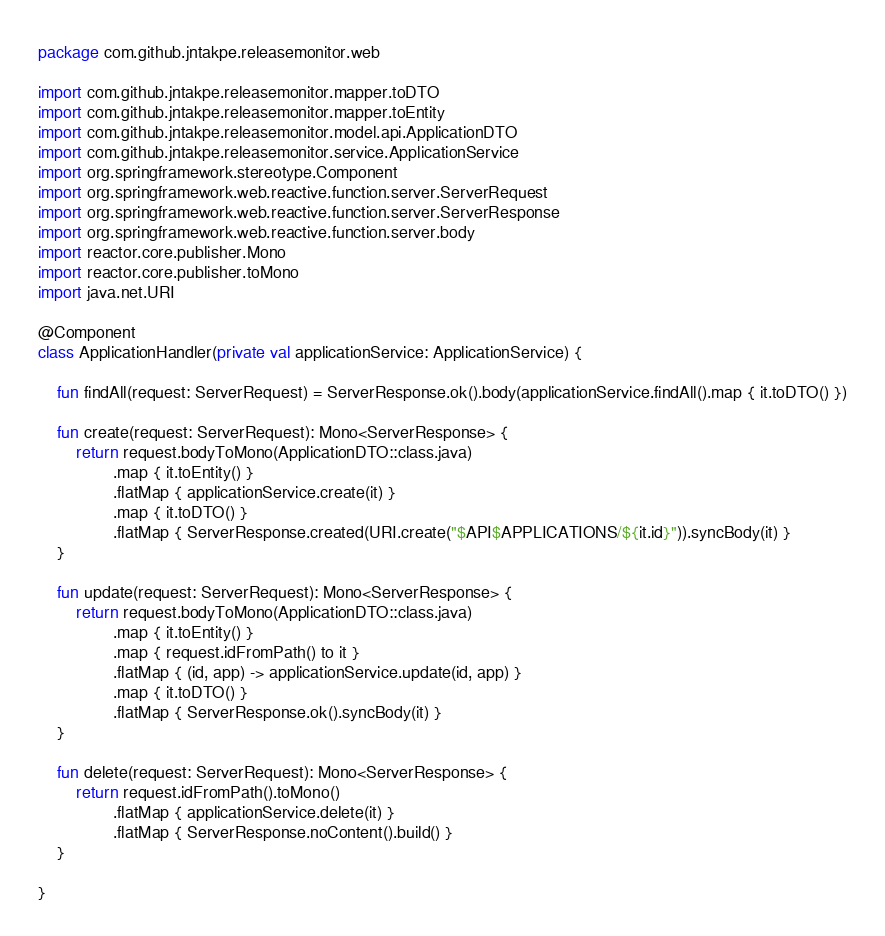<code> <loc_0><loc_0><loc_500><loc_500><_Kotlin_>package com.github.jntakpe.releasemonitor.web

import com.github.jntakpe.releasemonitor.mapper.toDTO
import com.github.jntakpe.releasemonitor.mapper.toEntity
import com.github.jntakpe.releasemonitor.model.api.ApplicationDTO
import com.github.jntakpe.releasemonitor.service.ApplicationService
import org.springframework.stereotype.Component
import org.springframework.web.reactive.function.server.ServerRequest
import org.springframework.web.reactive.function.server.ServerResponse
import org.springframework.web.reactive.function.server.body
import reactor.core.publisher.Mono
import reactor.core.publisher.toMono
import java.net.URI

@Component
class ApplicationHandler(private val applicationService: ApplicationService) {

    fun findAll(request: ServerRequest) = ServerResponse.ok().body(applicationService.findAll().map { it.toDTO() })

    fun create(request: ServerRequest): Mono<ServerResponse> {
        return request.bodyToMono(ApplicationDTO::class.java)
                .map { it.toEntity() }
                .flatMap { applicationService.create(it) }
                .map { it.toDTO() }
                .flatMap { ServerResponse.created(URI.create("$API$APPLICATIONS/${it.id}")).syncBody(it) }
    }

    fun update(request: ServerRequest): Mono<ServerResponse> {
        return request.bodyToMono(ApplicationDTO::class.java)
                .map { it.toEntity() }
                .map { request.idFromPath() to it }
                .flatMap { (id, app) -> applicationService.update(id, app) }
                .map { it.toDTO() }
                .flatMap { ServerResponse.ok().syncBody(it) }
    }

    fun delete(request: ServerRequest): Mono<ServerResponse> {
        return request.idFromPath().toMono()
                .flatMap { applicationService.delete(it) }
                .flatMap { ServerResponse.noContent().build() }
    }

}</code> 